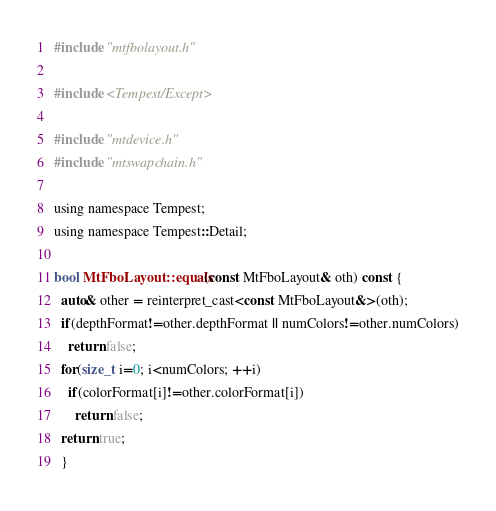Convert code to text. <code><loc_0><loc_0><loc_500><loc_500><_ObjectiveC_>#include "mtfbolayout.h"

#include <Tempest/Except>

#include "mtdevice.h"
#include "mtswapchain.h"

using namespace Tempest;
using namespace Tempest::Detail;

bool MtFboLayout::equals(const MtFboLayout& oth) const {
  auto& other = reinterpret_cast<const MtFboLayout&>(oth);
  if(depthFormat!=other.depthFormat || numColors!=other.numColors)
    return false;
  for(size_t i=0; i<numColors; ++i)
    if(colorFormat[i]!=other.colorFormat[i])
      return false;
  return true;
  }
</code> 